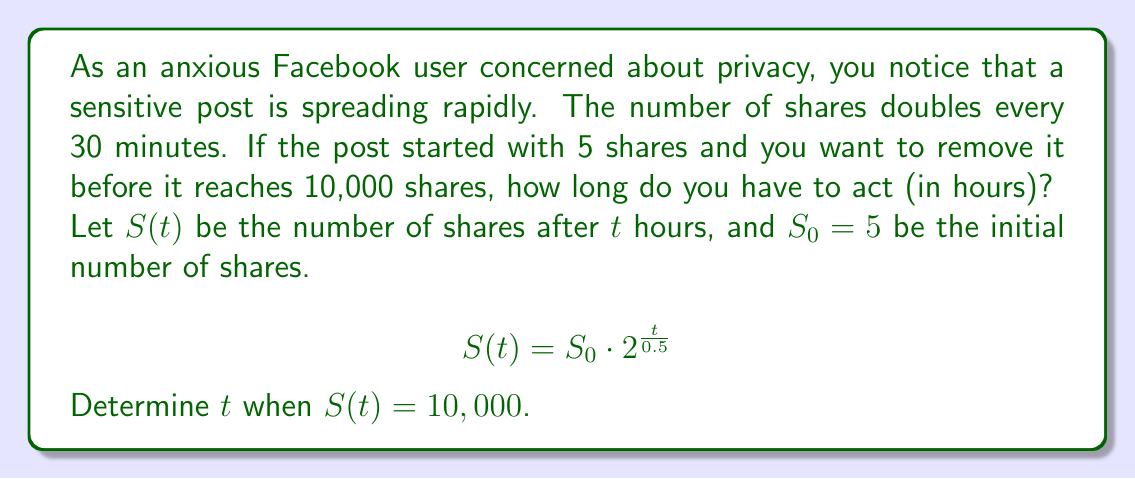Provide a solution to this math problem. To solve this problem, we'll use the exponential growth formula and logarithms:

1) We start with the given equation:
   $$S(t) = S_0 \cdot 2^{\frac{t}{0.5}}$$

2) Substitute the known values:
   $$10,000 = 5 \cdot 2^{\frac{t}{0.5}}$$

3) Divide both sides by 5:
   $$2,000 = 2^{\frac{t}{0.5}}$$

4) Take the logarithm (base 2) of both sides:
   $$\log_2(2,000) = \frac{t}{0.5}$$

5) Simplify the left side:
   $$\frac{\log(2,000)}{\log(2)} = \frac{t}{0.5}$$

6) Multiply both sides by 0.5:
   $$0.5 \cdot \frac{\log(2,000)}{\log(2)} = t$$

7) Calculate the result:
   $$t \approx 5.4739 \text{ hours}$$

This means you have approximately 5.47 hours to act before the post reaches 10,000 shares.
Answer: $t \approx 5.47 \text{ hours}$ 